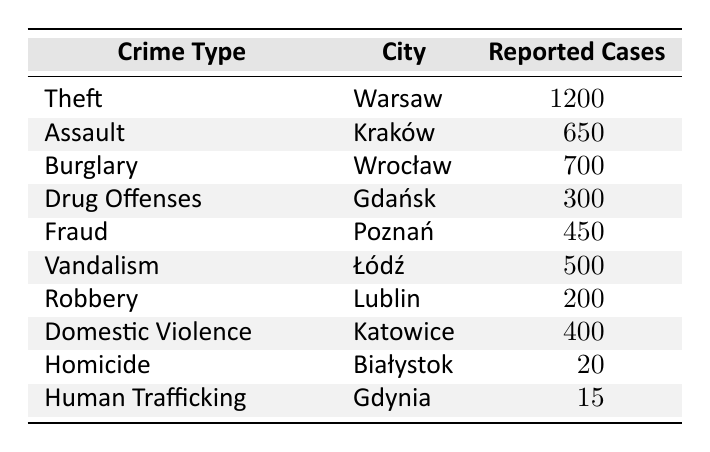What city has the highest reported cases of theft? According to the table, Warsaw has the highest reported cases of theft with 1200 cases.
Answer: Warsaw How many cases of assault were reported in Kraków? The table indicates that Kraków reported 650 cases of assault.
Answer: 650 Is there more reported domestic violence or drug offenses? Domestic violence has 400 reported cases, while drug offenses have 300 cases, indicating that domestic violence is higher.
Answer: Yes What is the total number of reported cases for burglary and vandalism combined? To find the total, we add burglary (700 cases) and vandalism (500 cases): 700 + 500 = 1200.
Answer: 1200 Which city reported the least number of cases and what crime type was it? Białystok reported the least number of cases with 20 cases of homicide.
Answer: Białystok, Homicide What is the average number of reported cases across all crime types? The total number of reported cases is 1200 + 650 + 700 + 300 + 450 + 500 + 200 + 400 + 20 + 15 = 4145. There are 10 crime types, so the average is 4145 / 10 = 414.5.
Answer: 414.5 Does Gdańsk have a higher reported crime for drug offenses compared to Lublin's robbery? Gdańsk reported 300 cases of drug offenses while Lublin reported 200 cases of robbery; therefore, Gdańsk has a higher number of cases.
Answer: Yes If we remove the cases of homicide and human trafficking, what are the reported cases for the remaining crime types? Removing homicide (20 cases) and human trafficking (15 cases) leaves us with total cases of 4145 - (20 + 15) = 4110 for the remaining crime types.
Answer: 4110 